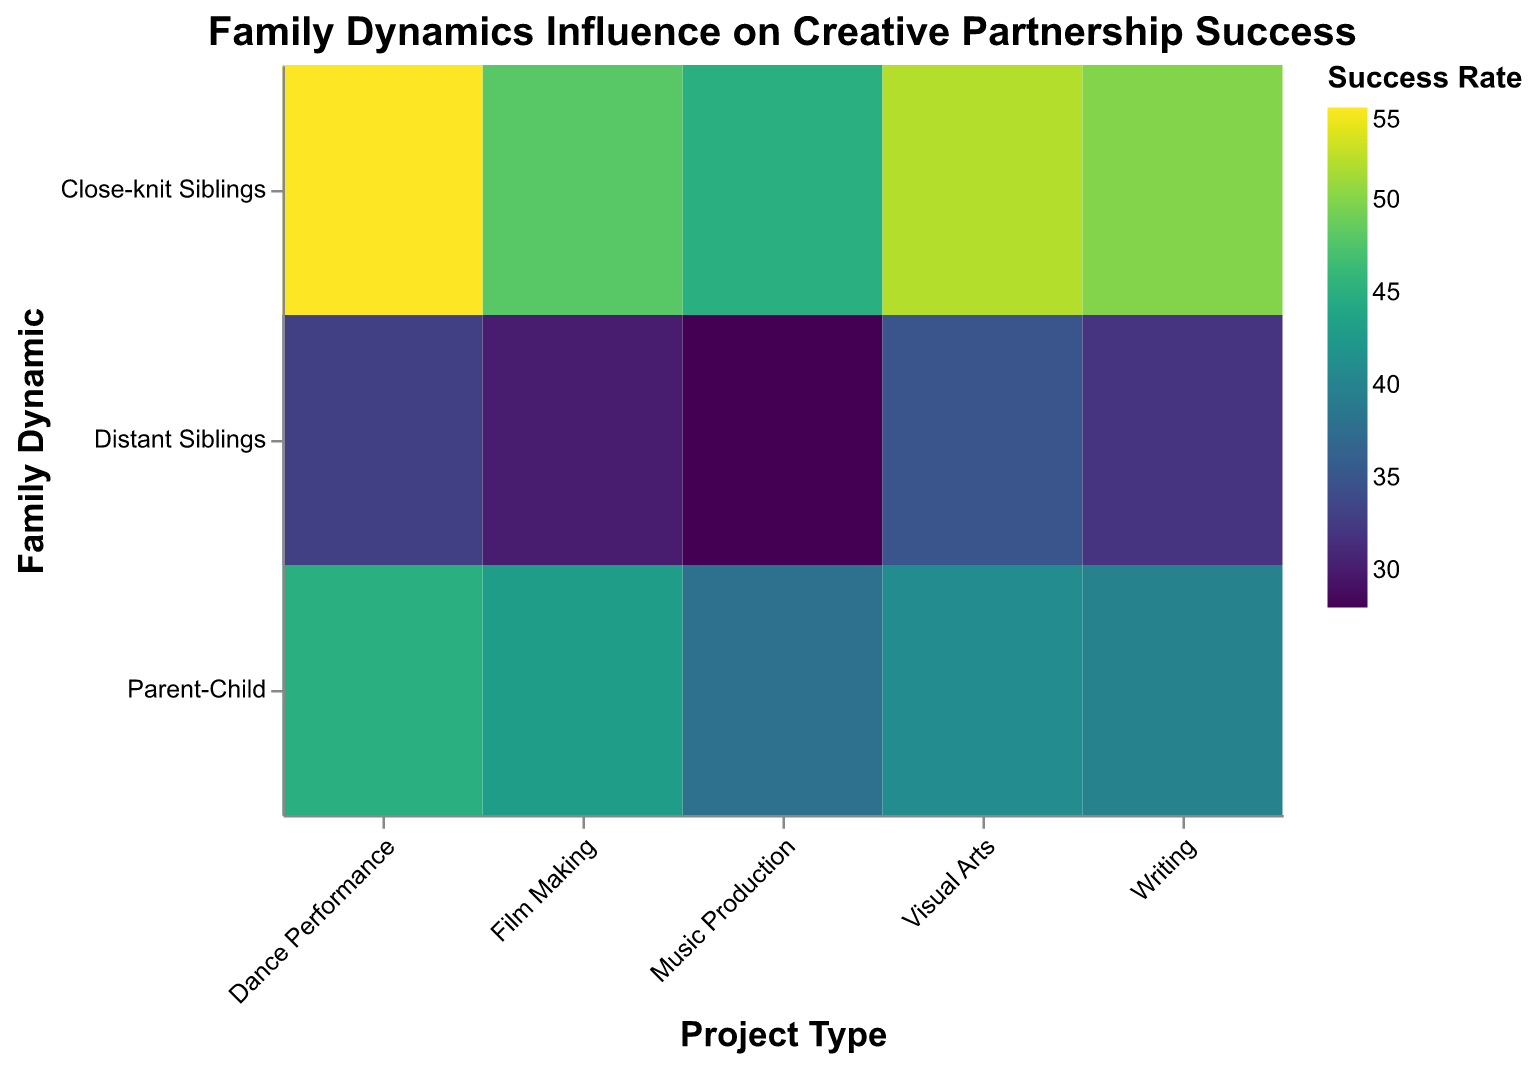How many project types are displayed in the figure? The x-axis of the figure is labeled "Project Type," and it shows five distinct categories: Music Production, Visual Arts, Film Making, Writing, and Dance Performance.
Answer: 5 Which family dynamic has the highest success rate in Dance Performance? By looking at the Dance Performance column and the color and size of the rectangles, the "Close-knit Siblings" group has the darkest shade and largest size, indicating the highest success rate.
Answer: Close-knit Siblings What is the success rate difference between Close-knit Siblings and Distant Siblings in Writing? Refer to the Writing column in the figure. Close-knit Siblings have a success rate of 50, and Distant Siblings have a success rate of 32. The difference is 50 - 32.
Answer: 18 Which project type shows the least variation in success rates across different family dynamics? Analyze the color gradient and size of the rectangles within each project type column. Film Making shows relatively similar color shades and sizes across Close-knit Siblings, Distant Siblings, and Parent-Child.
Answer: Film Making Compare the success rates of Parent-Child for Music Production and Dance Performance. Which one is higher? Examine the color shades and sizes of the rectangles for Parent-Child in Music Production and Dance Performance. Dance Performance has a darker shade and larger size compared to Music Production.
Answer: Dance Performance What is the average success rate for Close-knit Siblings across all project types? Calculate the average by summing the success rates for Close-knit Siblings (45, 52, 48, 50, 55) and dividing by the number of project types (5). The sum is 45 + 52 + 48 + 50 + 55 = 250, so the average is 250 / 5.
Answer: 50 Which family dynamic generally has the lowest success rates across project types? By observing the overall color and size for each family dynamic across the figure, Distant Siblings have lighter shades and smaller sizes, indicating generally lower success rates.
Answer: Distant Siblings In which project type do Parent-Child partnerships have the highest success rate? Look at the color shades and sizes of the rectangles for Parent-Child across different project types. The darkest shade and largest size for Parent-Child are in Dance Performance with a success rate of 45.
Answer: Dance Performance What is the total success rate for Distant Siblings across all project types? Sum the success rates for Distant Siblings across all project types (28, 35, 30, 32, 33). The total is 28 + 35 + 30 + 32 + 33 = 158.
Answer: 158 Compare the success rates of Close-knit Siblings and Parent-Child in Visual Arts. Which is higher and by how much? In Visual Arts, Close-knit Siblings have a success rate of 52, and Parent-Child have a success rate of 41. The difference is 52 - 41.
Answer: Close-knit Siblings by 11 